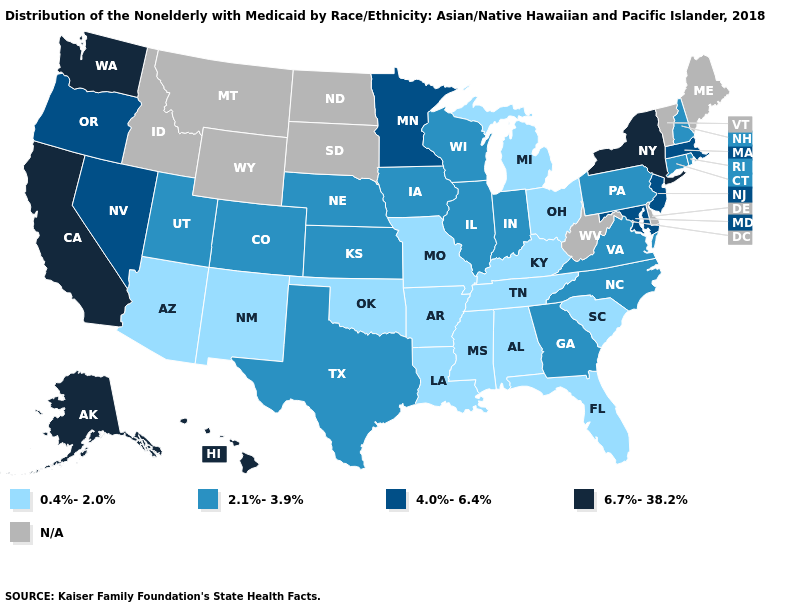What is the lowest value in states that border Missouri?
Write a very short answer. 0.4%-2.0%. Does Rhode Island have the highest value in the USA?
Quick response, please. No. Is the legend a continuous bar?
Give a very brief answer. No. Is the legend a continuous bar?
Short answer required. No. What is the value of Michigan?
Concise answer only. 0.4%-2.0%. What is the highest value in the Northeast ?
Write a very short answer. 6.7%-38.2%. Name the states that have a value in the range 6.7%-38.2%?
Keep it brief. Alaska, California, Hawaii, New York, Washington. What is the lowest value in states that border Utah?
Answer briefly. 0.4%-2.0%. Among the states that border Tennessee , does Virginia have the highest value?
Keep it brief. Yes. Does Kansas have the highest value in the MidWest?
Answer briefly. No. Name the states that have a value in the range 4.0%-6.4%?
Be succinct. Maryland, Massachusetts, Minnesota, Nevada, New Jersey, Oregon. Name the states that have a value in the range 6.7%-38.2%?
Concise answer only. Alaska, California, Hawaii, New York, Washington. What is the value of Nevada?
Give a very brief answer. 4.0%-6.4%. Name the states that have a value in the range 6.7%-38.2%?
Keep it brief. Alaska, California, Hawaii, New York, Washington. 